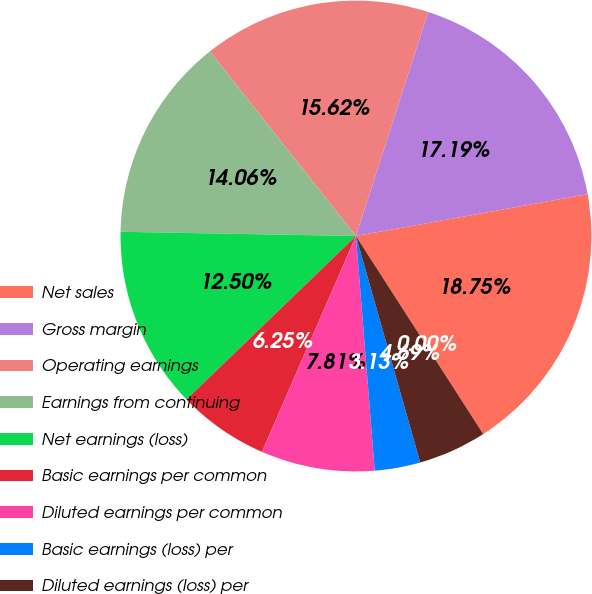<chart> <loc_0><loc_0><loc_500><loc_500><pie_chart><fcel>Net sales<fcel>Gross margin<fcel>Operating earnings<fcel>Earnings from continuing<fcel>Net earnings (loss)<fcel>Basic earnings per common<fcel>Diluted earnings per common<fcel>Basic earnings (loss) per<fcel>Diluted earnings (loss) per<fcel>Dividends declared<nl><fcel>18.75%<fcel>17.19%<fcel>15.62%<fcel>14.06%<fcel>12.5%<fcel>6.25%<fcel>7.81%<fcel>3.13%<fcel>4.69%<fcel>0.0%<nl></chart> 